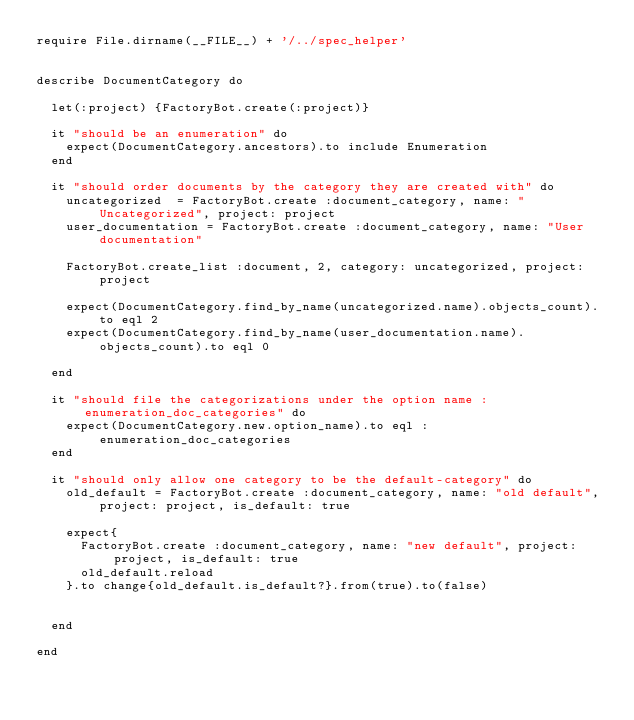Convert code to text. <code><loc_0><loc_0><loc_500><loc_500><_Ruby_>require File.dirname(__FILE__) + '/../spec_helper'


describe DocumentCategory do

  let(:project) {FactoryBot.create(:project)}

  it "should be an enumeration" do
    expect(DocumentCategory.ancestors).to include Enumeration
  end

  it "should order documents by the category they are created with" do
    uncategorized  = FactoryBot.create :document_category, name: "Uncategorized", project: project
    user_documentation = FactoryBot.create :document_category, name: "User documentation"

    FactoryBot.create_list :document, 2, category: uncategorized, project: project

    expect(DocumentCategory.find_by_name(uncategorized.name).objects_count).to eql 2
    expect(DocumentCategory.find_by_name(user_documentation.name).objects_count).to eql 0

  end

  it "should file the categorizations under the option name :enumeration_doc_categories" do
    expect(DocumentCategory.new.option_name).to eql :enumeration_doc_categories
  end

  it "should only allow one category to be the default-category" do
    old_default = FactoryBot.create :document_category, name: "old default", project: project, is_default: true

    expect{
      FactoryBot.create :document_category, name: "new default", project: project, is_default: true
      old_default.reload
    }.to change{old_default.is_default?}.from(true).to(false)


  end

end
</code> 